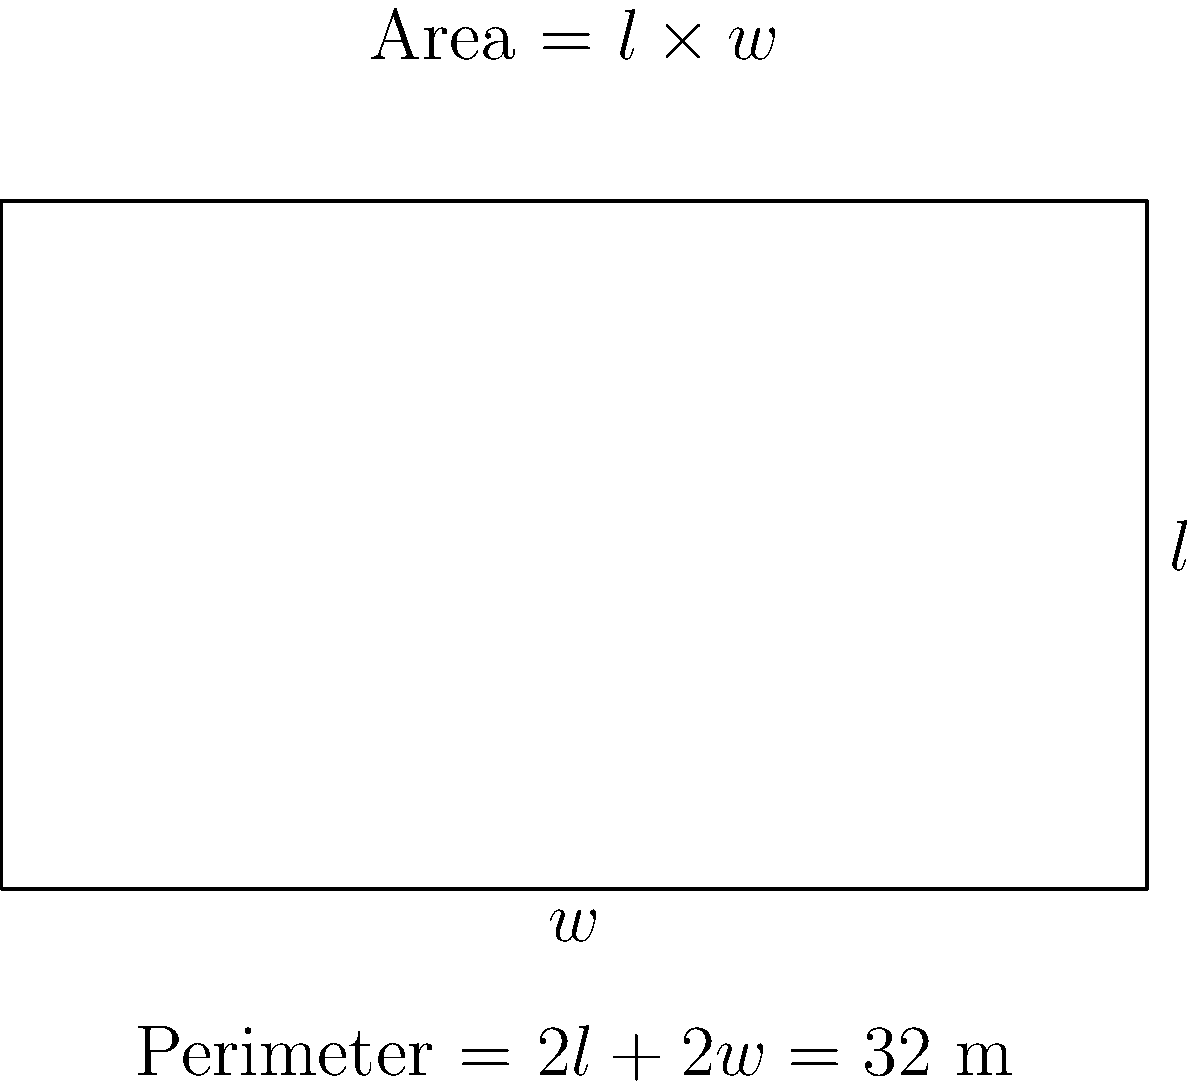As an entrepreneur planning for retirement, you're designing a new office space. You have a fixed amount of material to construct the walls, resulting in a perimeter of 32 meters. What dimensions (length and width) should you choose for your rectangular office to maximize the floor area? Let's approach this step-by-step:

1) Let $l$ be the length and $w$ be the width of the rectangle.

2) Given that the perimeter is 32 meters, we can write:
   $2l + 2w = 32$
   $l + w = 16$ (dividing both sides by 2)

3) We want to maximize the area, which is given by $A = l \times w$

4) We can express $w$ in terms of $l$:
   $w = 16 - l$

5) Now, we can write the area as a function of $l$:
   $A(l) = l(16-l) = 16l - l^2$

6) To find the maximum, we differentiate $A$ with respect to $l$ and set it to zero:
   $\frac{dA}{dl} = 16 - 2l = 0$
   $16 = 2l$
   $l = 8$

7) Since $l + w = 16$, we can find $w$:
   $8 + w = 16$
   $w = 8$

8) To confirm this is a maximum (not a minimum), we can check the second derivative:
   $\frac{d^2A}{dl^2} = -2$, which is negative, confirming a maximum.

Therefore, to maximize the area, the office should be a square with both length and width equal to 8 meters.
Answer: Length = 8 m, Width = 8 m 